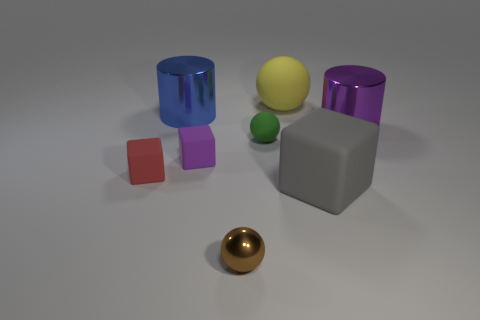What is the size of the gray rubber object?
Make the answer very short. Large. How many things are small brown metal balls or brown metal objects that are to the right of the tiny purple matte cube?
Ensure brevity in your answer.  1. How many other things are the same color as the big block?
Provide a succinct answer. 0. Is the size of the brown metallic thing the same as the cylinder that is to the left of the yellow rubber sphere?
Provide a short and direct response. No. Does the cylinder that is on the left side of the green rubber thing have the same size as the yellow rubber ball?
Offer a terse response. Yes. How many other objects are the same material as the blue cylinder?
Give a very brief answer. 2. Is the number of tiny blocks right of the red cube the same as the number of rubber objects that are behind the green rubber object?
Provide a succinct answer. Yes. There is a cylinder behind the cylinder right of the large cylinder behind the big purple cylinder; what is its color?
Give a very brief answer. Blue. What is the shape of the large matte thing behind the big blue thing?
Offer a very short reply. Sphere. What is the shape of the purple thing that is made of the same material as the large yellow ball?
Your answer should be very brief. Cube. 